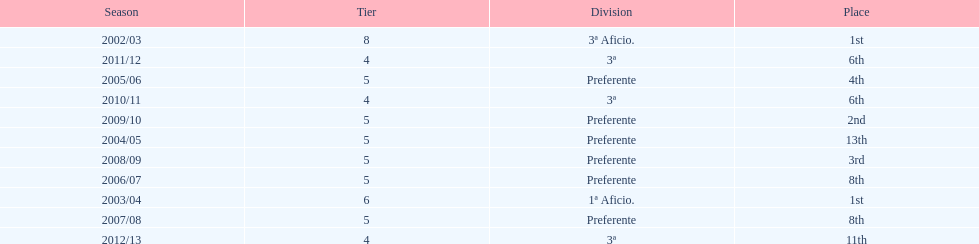In what year did the team achieve the same place as 2010/11? 2011/12. 